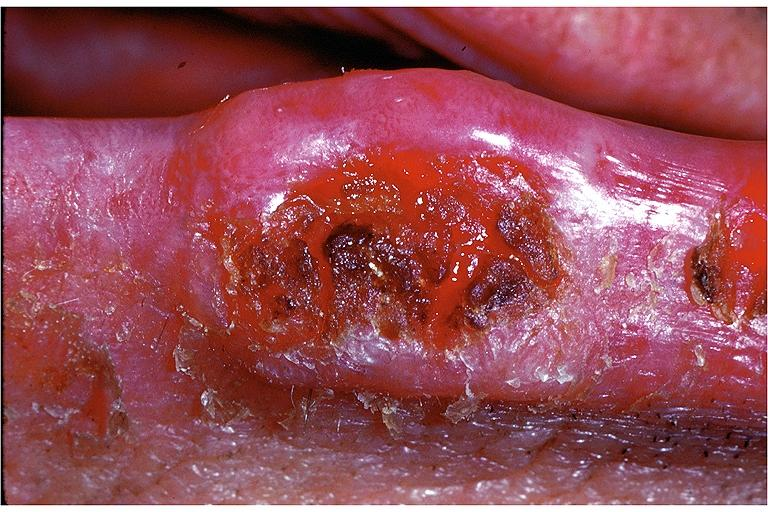does leukoplakia vocal cord show squamous cell carcinoma?
Answer the question using a single word or phrase. No 